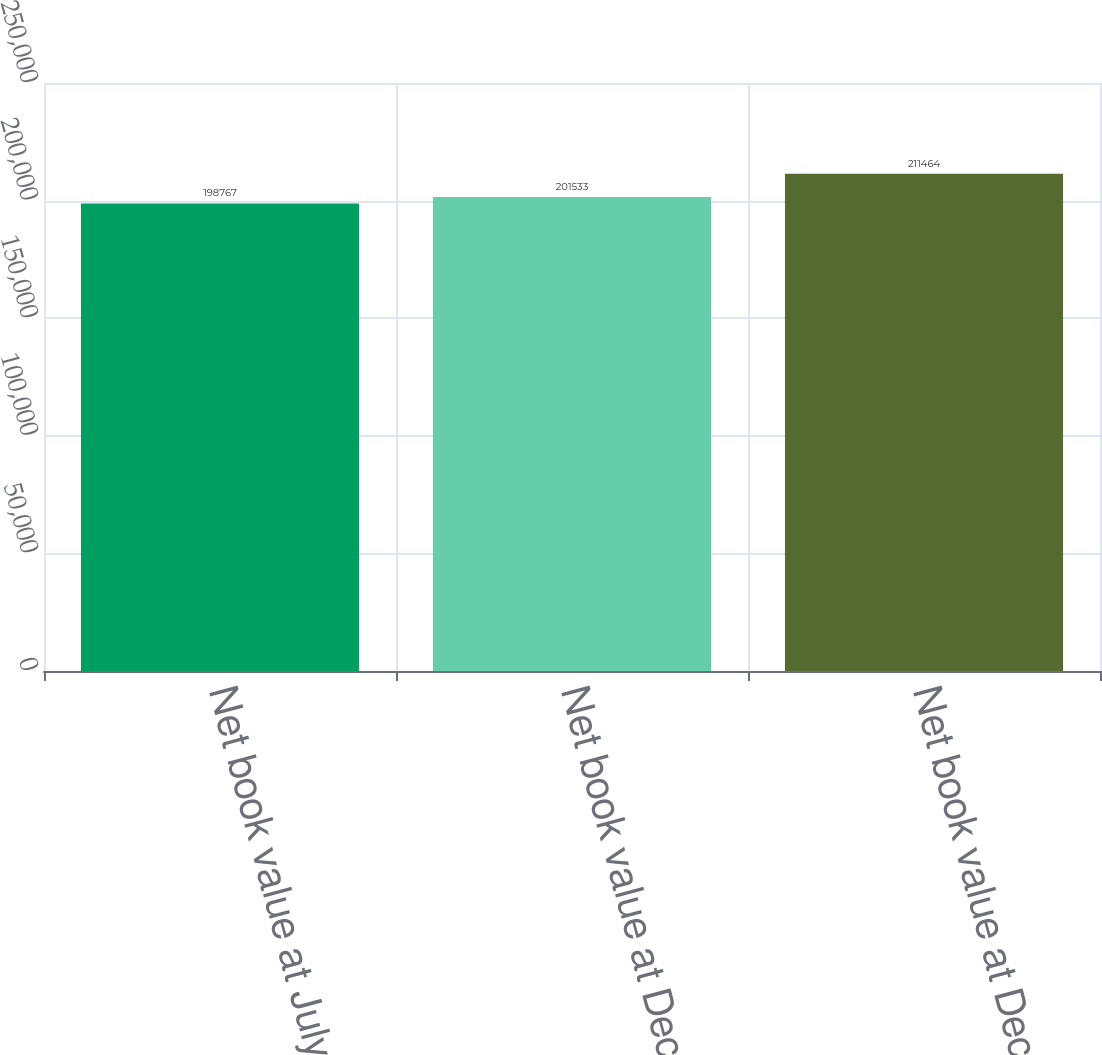Convert chart to OTSL. <chart><loc_0><loc_0><loc_500><loc_500><bar_chart><fcel>Net book value at July 1 2006<fcel>Net book value at December 30<fcel>Net book value at December 29<nl><fcel>198767<fcel>201533<fcel>211464<nl></chart> 